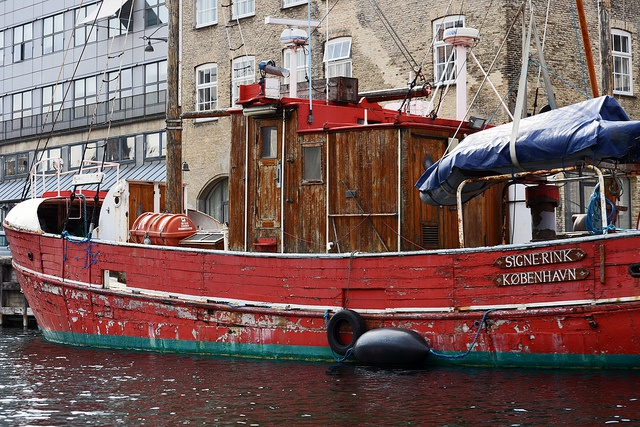Describe the objects in this image and their specific colors. I can see a boat in lightgray, maroon, brown, and black tones in this image. 